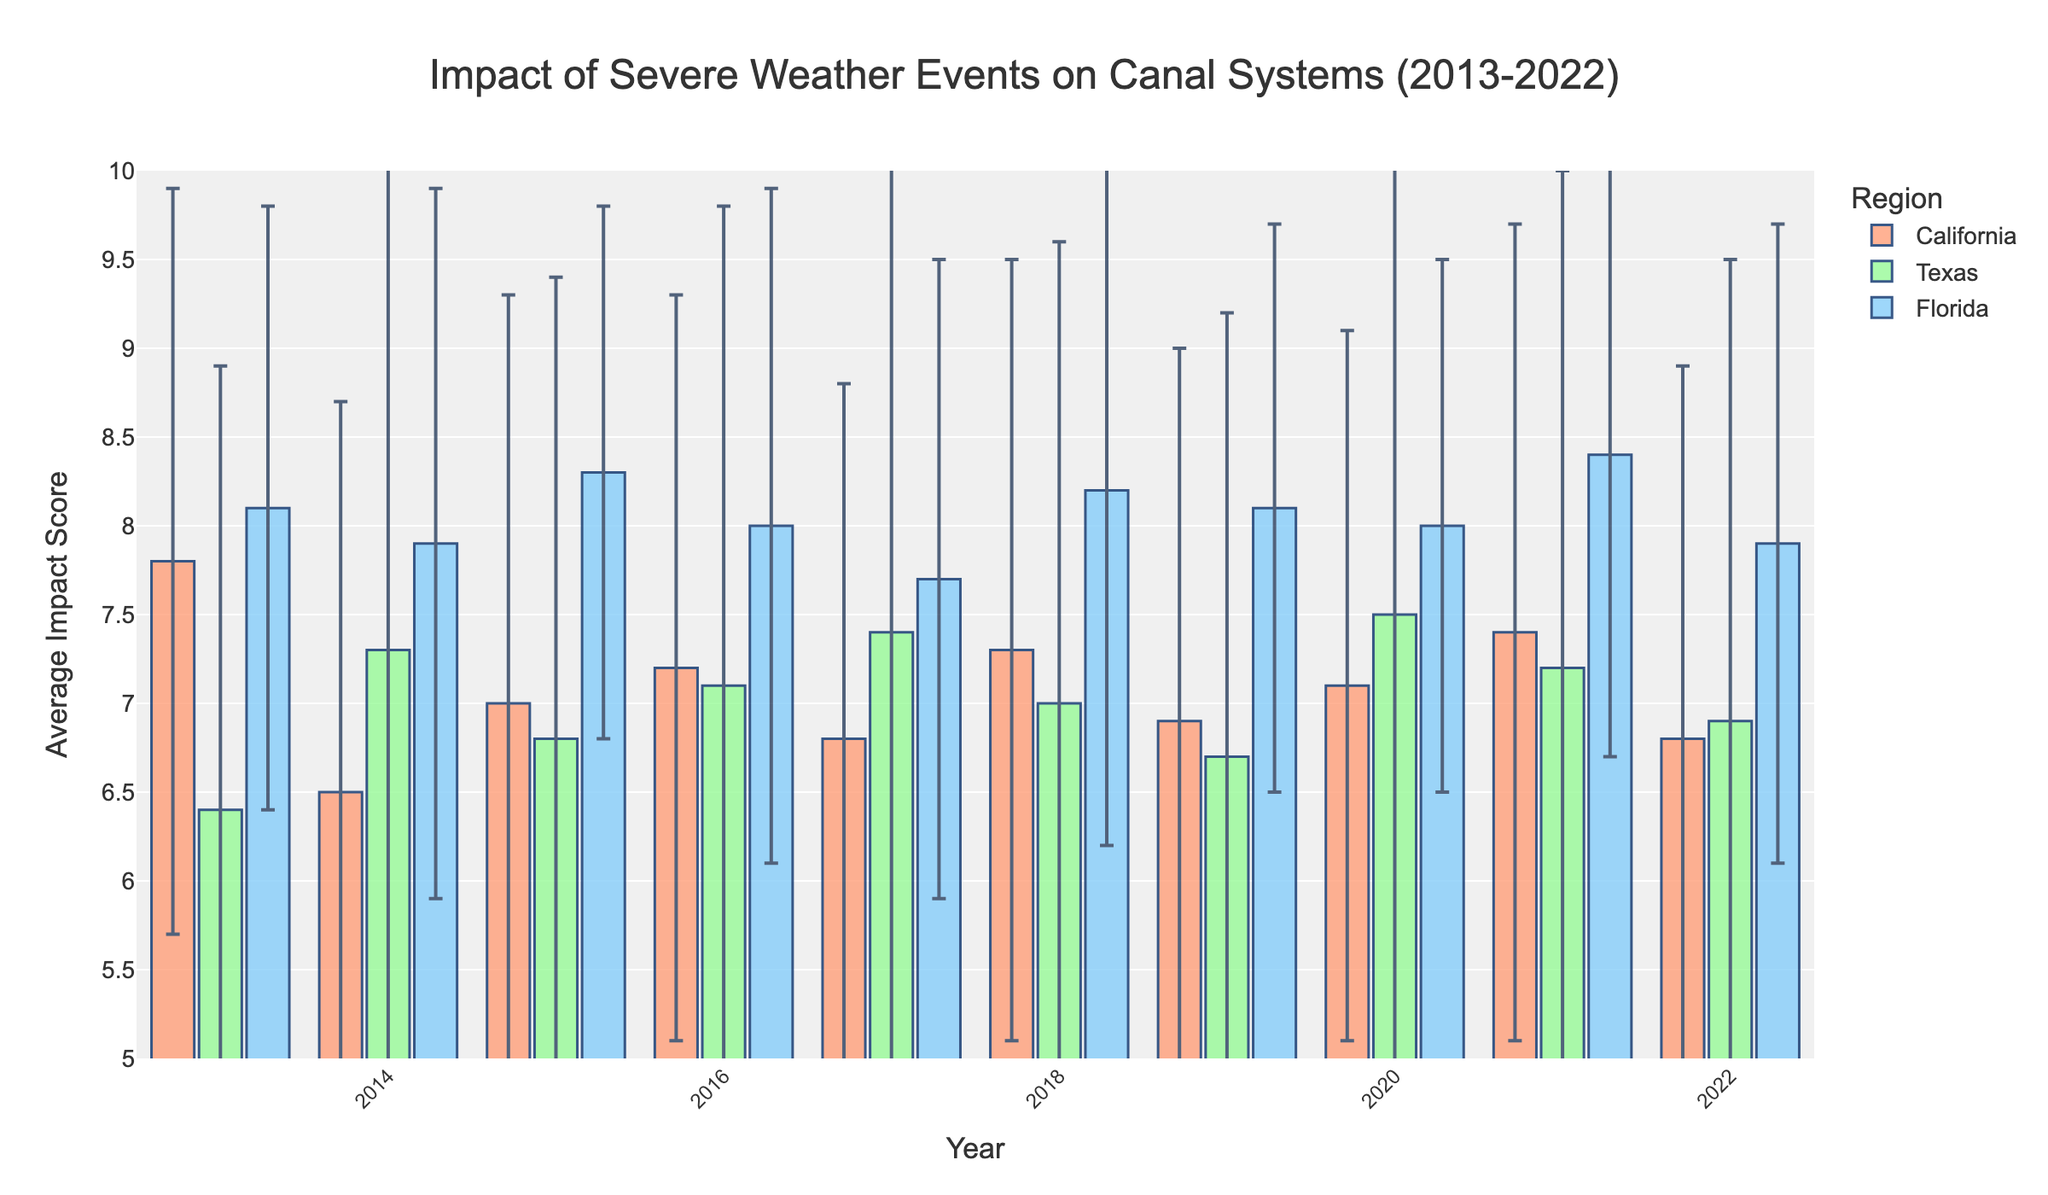What is the title of the bar chart? The title is located at the top of the chart and describes the content. It reads, "Impact of Severe Weather Events on Canal Systems (2013-2022)."
Answer: Impact of Severe Weather Events on Canal Systems (2013-2022) What are the regions compared in the chart? There are three distinct color-coded bars representing different regions in the chart. The legend at the bottom identifies them as California, Texas, and Florida.
Answer: California, Texas, and Florida Which region had the highest average impact score in 2021? In 2021, the bar with the highest value on the y-axis corresponds to Florida. This can be observed directly from the height of the bars in that year.
Answer: Florida What is the range of average impact scores shown in the y-axis? The y-axis starts at 5 and goes up to 10, as indicated by the labeled ticks along the axis.
Answer: 5 to 10 How many severe weather events occurred in California in 2018? The data shows the number of severe weather events per year for each region. In 2018, California had 7 severe weather events.
Answer: 7 Which year did Texas experience the lowest average impact score? By looking at the height of the bars for Texas across the years, the lowest average impact score for Texas appears in 2013.
Answer: 2013 What was Florida's average impact score in 2014? To find this, look at the bar representing Florida in 2014. The height of the bar indicates an average impact score around 7.9.
Answer: 7.9 In which year did California and Texas have the same average impact score? Observing where the bars for California and Texas match in height, in the year 2019, both regions had an average impact score of approximately 6.9.
Answer: 2019 Which region shows the greatest variation in average impact score over the decade? The error bars represent the variation in the average impact score. Texas has the longest error bars on most years, indicating it has the greatest variance.
Answer: Texas Between 2016 and 2017, how did the average impact score change for Florida? By comparing the heights of Florida's bars between 2016 and 2017, the average impact score decreased from 8.0 to 7.7.
Answer: Decreased 